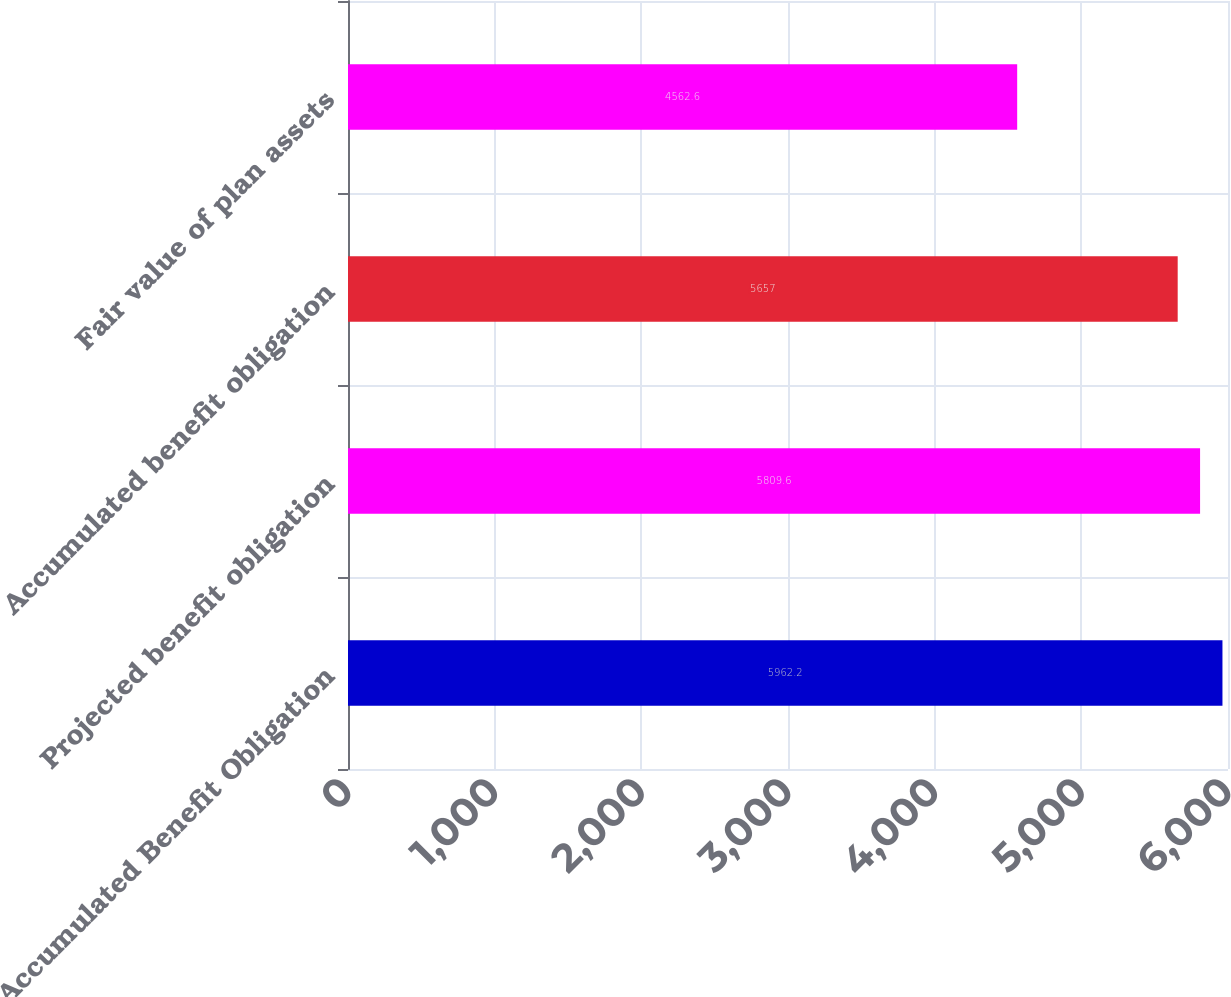<chart> <loc_0><loc_0><loc_500><loc_500><bar_chart><fcel>Accumulated Benefit Obligation<fcel>Projected benefit obligation<fcel>Accumulated benefit obligation<fcel>Fair value of plan assets<nl><fcel>5962.2<fcel>5809.6<fcel>5657<fcel>4562.6<nl></chart> 